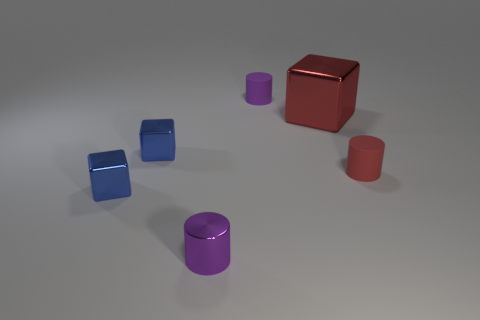Are there any red things that have the same material as the large cube?
Provide a succinct answer. No. There is a small object that is on the right side of the tiny purple cylinder to the right of the metal cylinder; what is it made of?
Keep it short and to the point. Rubber. What size is the purple cylinder that is behind the red rubber thing?
Give a very brief answer. Small. Does the large metallic thing have the same color as the rubber cylinder in front of the large red cube?
Make the answer very short. Yes. Are there any small shiny blocks that have the same color as the big metal block?
Give a very brief answer. No. Do the red cylinder and the small cylinder that is behind the big red cube have the same material?
Offer a very short reply. Yes. How many large things are either purple metal things or blue shiny things?
Provide a short and direct response. 0. There is a cylinder that is the same color as the big metallic cube; what material is it?
Your response must be concise. Rubber. Is the number of red rubber spheres less than the number of blue shiny blocks?
Make the answer very short. Yes. There is a blue cube in front of the red rubber cylinder; is its size the same as the cylinder left of the purple rubber object?
Offer a terse response. Yes. 